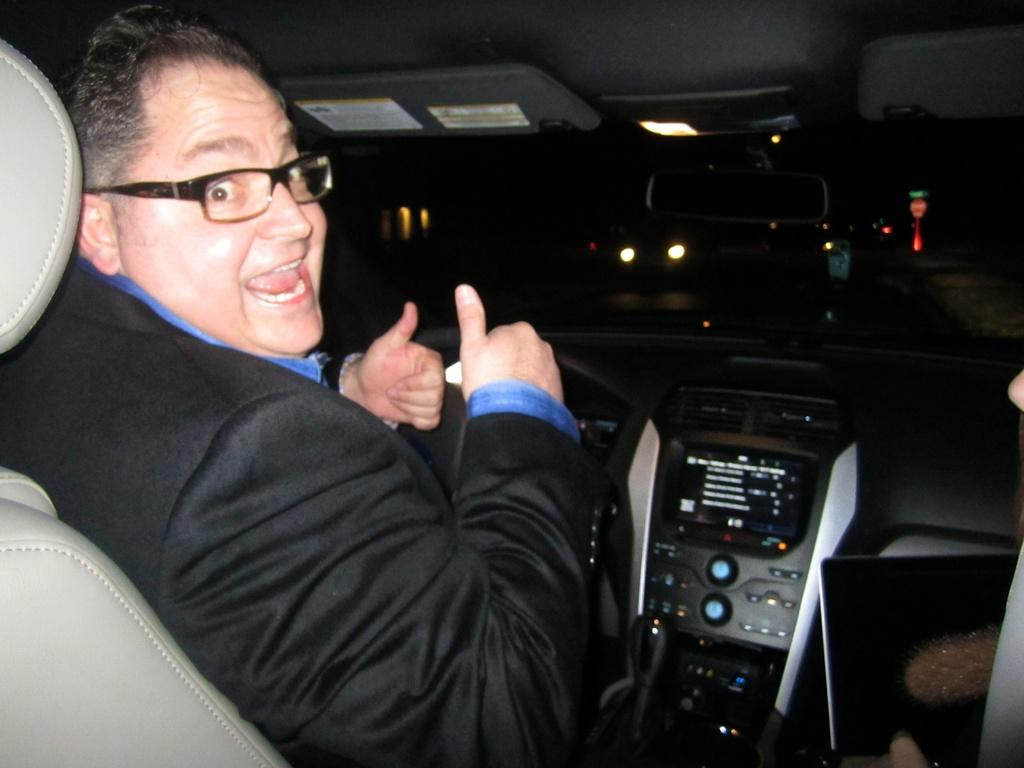What is the man in the image doing? The man is sitting in a car. Can you describe any accessories the man is wearing? The man is wearing glasses (specs). What else can be seen on the road in the image? There are other vehicles visible on the road. What is the price of the car the man is sitting in? The price of the car is not mentioned in the image, so it cannot be determined. 